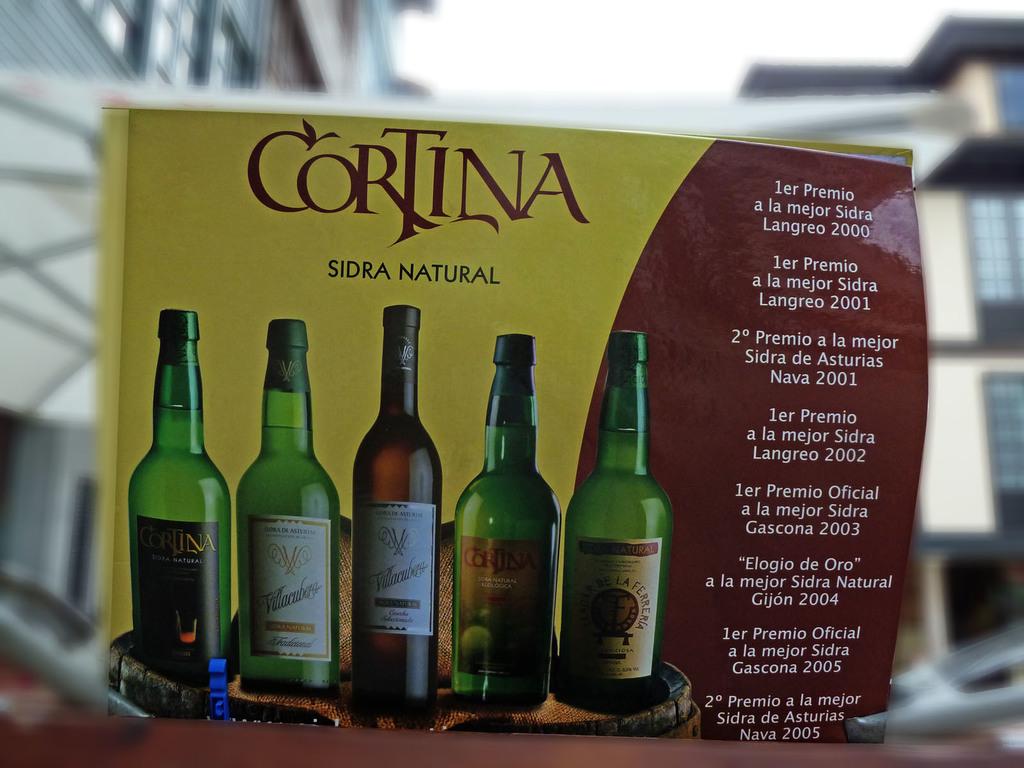What is the year for the first listed beer?
Keep it short and to the point. 2000. What is the title of the book?
Your answer should be compact. Cortina. 